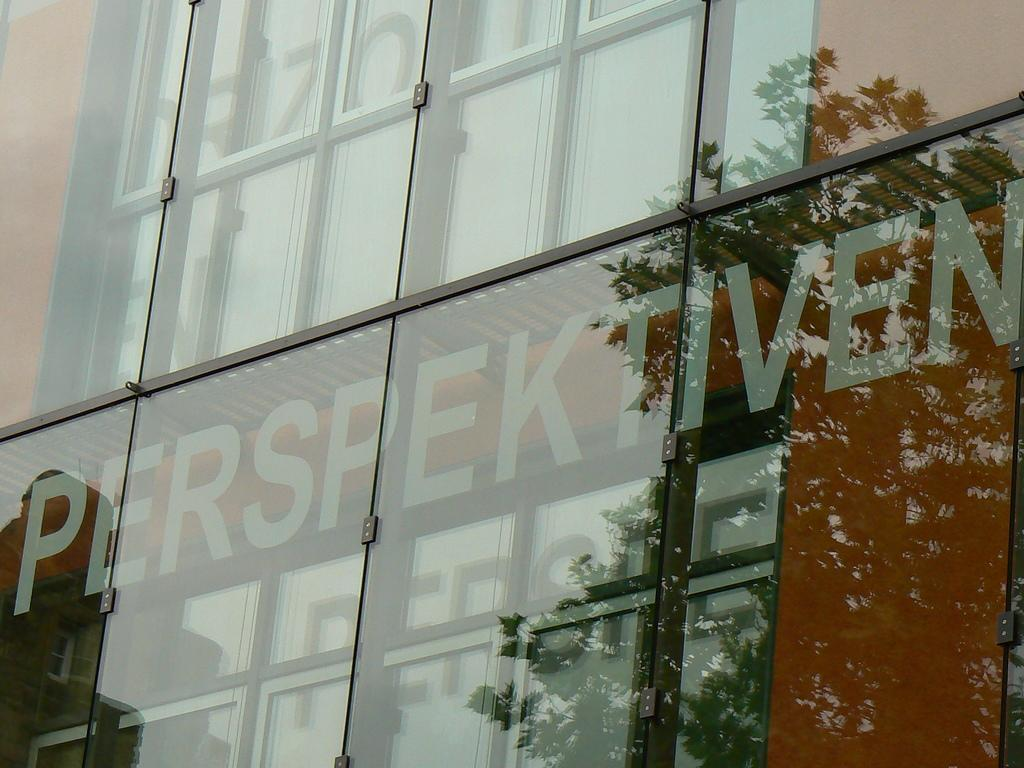What type of wall is present in the image? There is a glass wall in the image. What can be seen through the glass wall? Text on a board is visible through the glass wall. What is reflected on the glass wall? The reflection on the glass wall includes leaves of a tree. How many toes are visible on the person walking in the image? There is no person walking in the image, so no toes can be seen. 